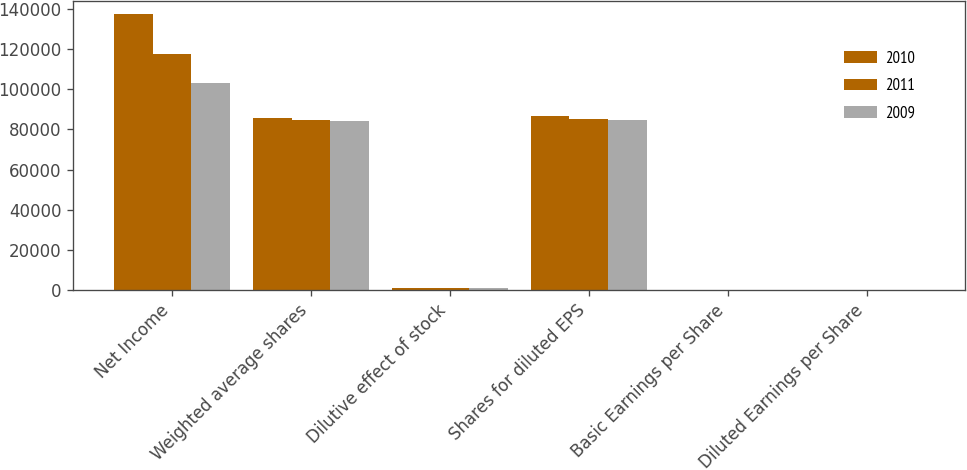Convert chart to OTSL. <chart><loc_0><loc_0><loc_500><loc_500><stacked_bar_chart><ecel><fcel>Net Income<fcel>Weighted average shares<fcel>Dilutive effect of stock<fcel>Shares for diluted EPS<fcel>Basic Earnings per Share<fcel>Diluted Earnings per Share<nl><fcel>2010<fcel>137471<fcel>85948<fcel>739<fcel>86687<fcel>1.6<fcel>1.59<nl><fcel>2011<fcel>117870<fcel>84558<fcel>823<fcel>85381<fcel>1.39<fcel>1.38<nl><fcel>2009<fcel>103102<fcel>84118<fcel>712<fcel>84830<fcel>1.23<fcel>1.22<nl></chart> 